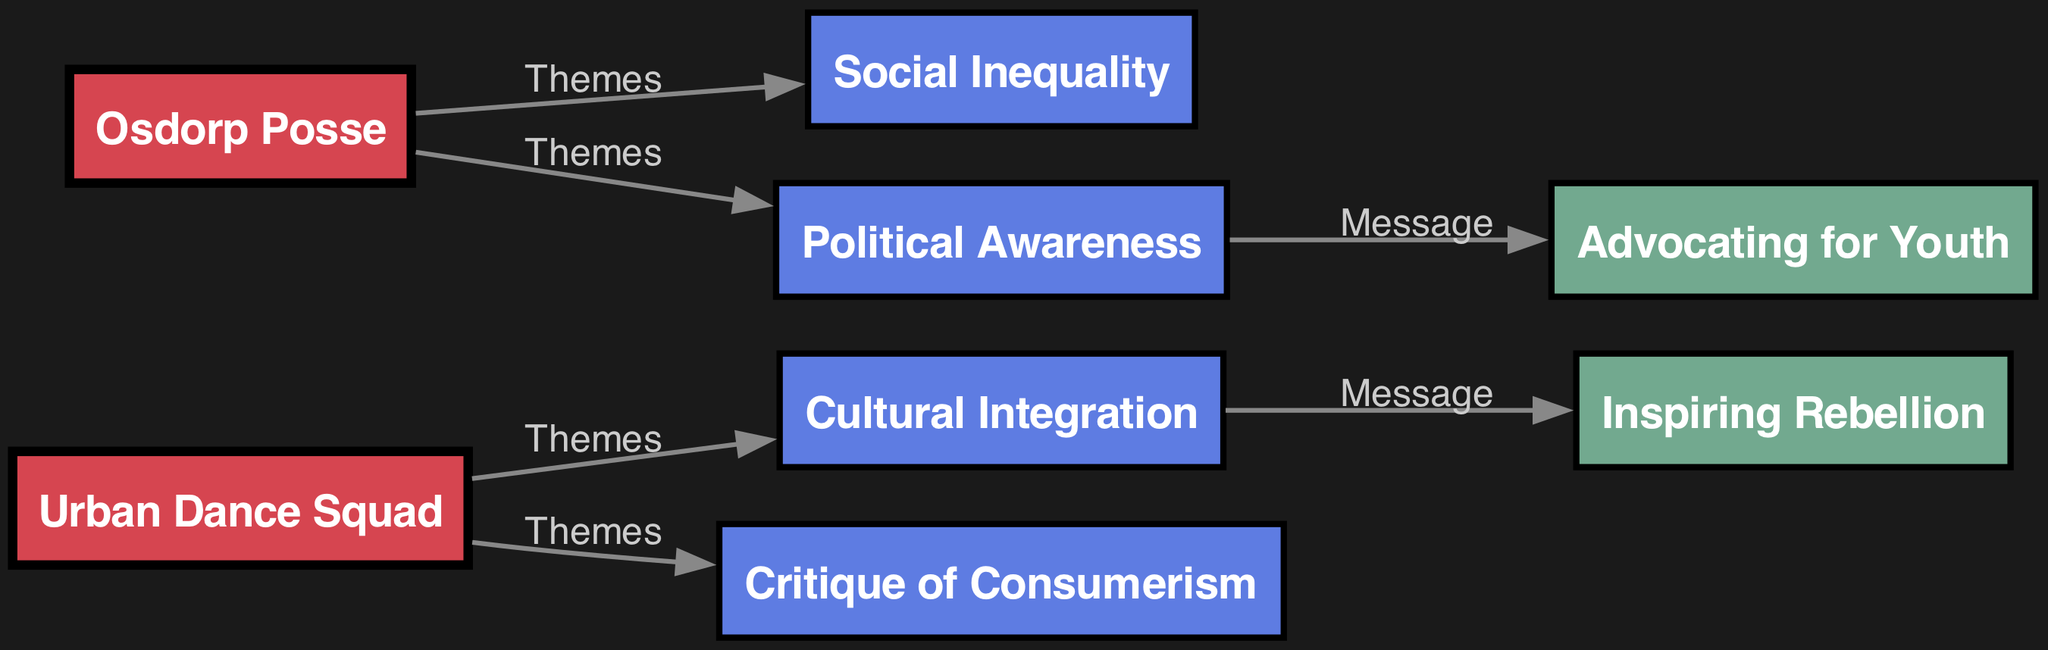What bands are represented in the diagram? The nodes labeled "Band" indicate the two represented bands: "Urban Dance Squad" and "Osdorp Posse."
Answer: Urban Dance Squad, Osdorp Posse What themes are linked to Urban Dance Squad? By examining the connections (edges) from "Urban Dance Squad," we see two themes: "Cultural Integration" and "Critique of Consumerism."
Answer: Cultural Integration, Critique of Consumerism How many themes are associated with Osdorp Posse? The edges connected to "Osdorp Posse" lead to two themes: "Social Inequality" and "Political Awareness," resulting in a total of two associated themes.
Answer: 2 Which theme leads to the message "Inspiring Rebellion"? The connection from "Cultural Integration" to the message "Inspiring Rebellion" shows that this theme leads to that message.
Answer: Cultural Integration What message is linked to the theme "Political Awareness"? The edge from "Political Awareness" leads to the message "Advocating for Youth," indicating this theme is connected to that message.
Answer: Advocating for Youth What is the total number of nodes in the diagram? Counting all the unique labeled nodes, we have eight in total: two bands, four themes, and two messages.
Answer: 8 Which theme addresses "Social Inequality"? The diagram indicates that "Social Inequality" is a theme associated directly with the band "Osdorp Posse."
Answer: Osdorp Posse How does "Critique of Consumerism" influence lyrical messages? The edge connecting "Critique of Consumerism" to "Inspiring Rebellion" suggests that this theme influences the message of rebellion in the lyrics.
Answer: Inspiring Rebellion What do the edges represent in this diagram? The edges indicate the relationships between the nodes, such as the connection of themes to bands and themes to messages.
Answer: Relationships 